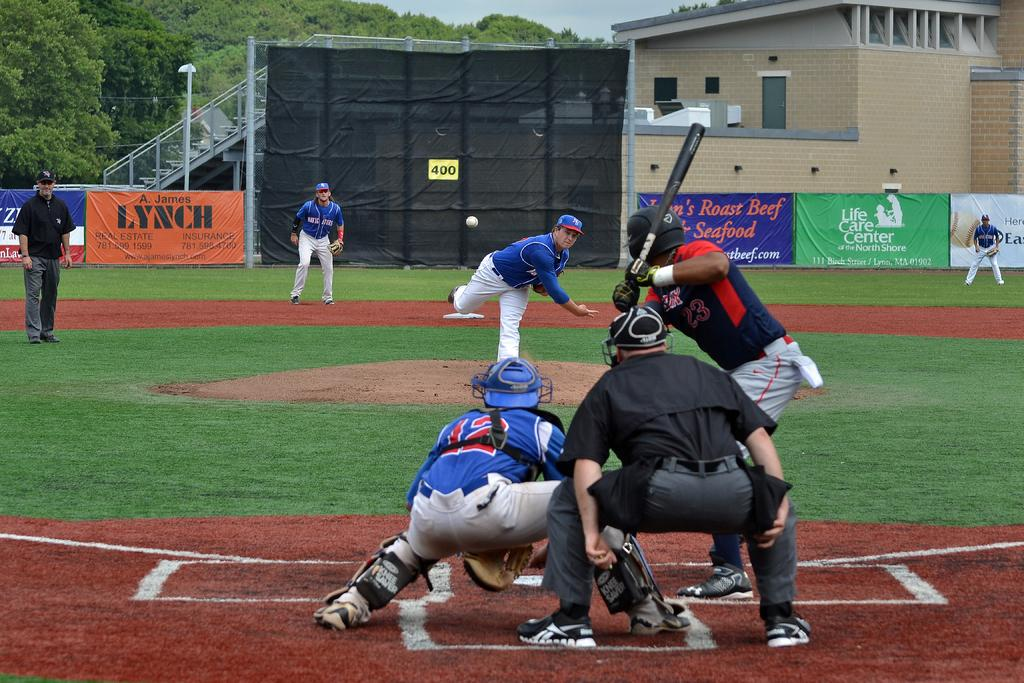<image>
Write a terse but informative summary of the picture. a catcher that has the number 12 on their jersey at a baseball game 